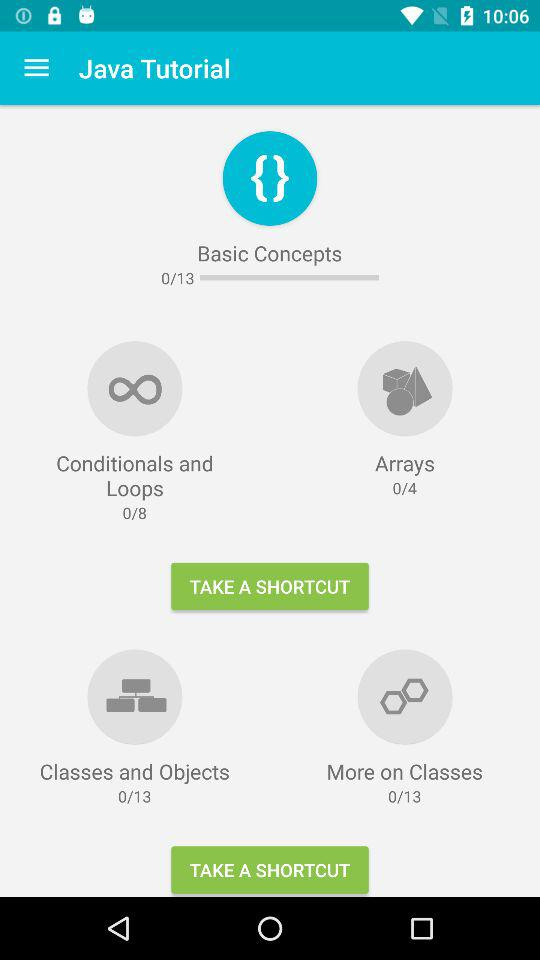What is the name of the tutorial? This is a "Java Tutorial". 